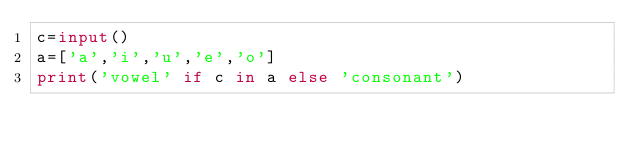Convert code to text. <code><loc_0><loc_0><loc_500><loc_500><_Python_>c=input()
a=['a','i','u','e','o']
print('vowel' if c in a else 'consonant')</code> 